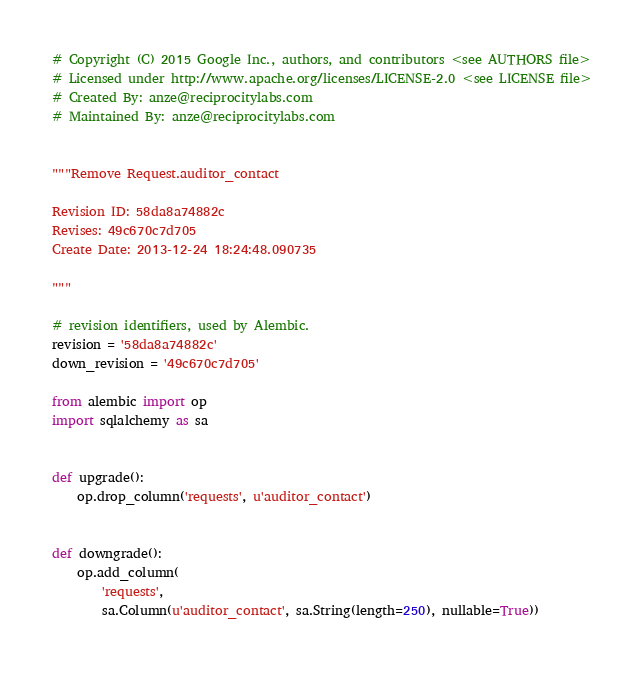<code> <loc_0><loc_0><loc_500><loc_500><_Python_># Copyright (C) 2015 Google Inc., authors, and contributors <see AUTHORS file>
# Licensed under http://www.apache.org/licenses/LICENSE-2.0 <see LICENSE file>
# Created By: anze@reciprocitylabs.com
# Maintained By: anze@reciprocitylabs.com


"""Remove Request.auditor_contact

Revision ID: 58da8a74882c
Revises: 49c670c7d705
Create Date: 2013-12-24 18:24:48.090735

"""

# revision identifiers, used by Alembic.
revision = '58da8a74882c'
down_revision = '49c670c7d705'

from alembic import op
import sqlalchemy as sa


def upgrade():
    op.drop_column('requests', u'auditor_contact')


def downgrade():
    op.add_column(
        'requests',
        sa.Column(u'auditor_contact', sa.String(length=250), nullable=True))
</code> 